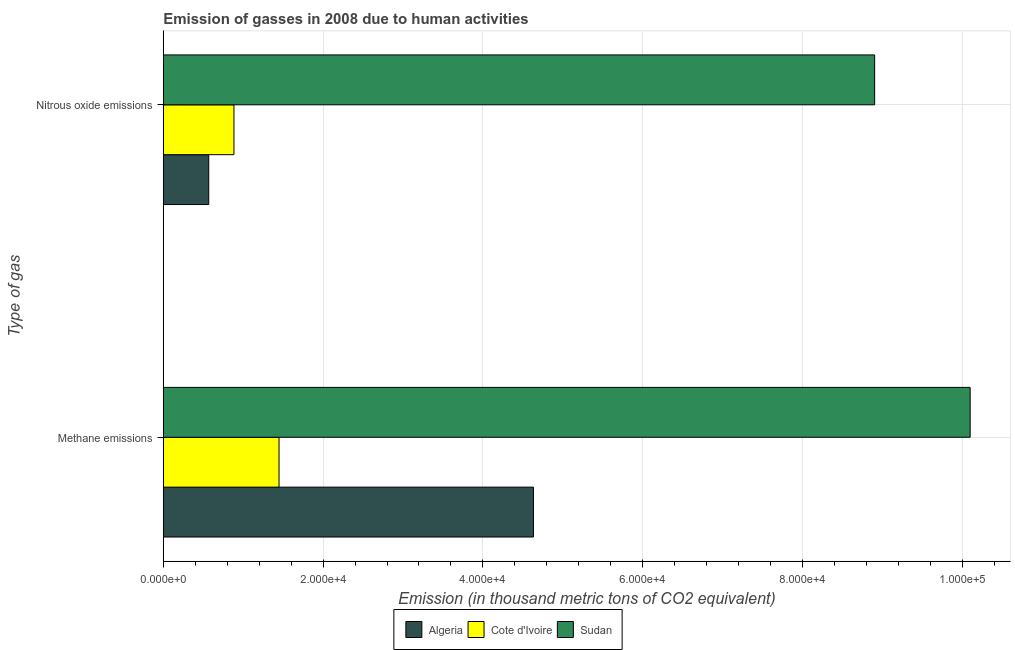How many different coloured bars are there?
Your answer should be very brief. 3. How many groups of bars are there?
Provide a succinct answer. 2. Are the number of bars per tick equal to the number of legend labels?
Offer a terse response. Yes. How many bars are there on the 1st tick from the bottom?
Offer a terse response. 3. What is the label of the 1st group of bars from the top?
Give a very brief answer. Nitrous oxide emissions. What is the amount of methane emissions in Algeria?
Make the answer very short. 4.63e+04. Across all countries, what is the maximum amount of nitrous oxide emissions?
Your answer should be very brief. 8.90e+04. Across all countries, what is the minimum amount of methane emissions?
Offer a very short reply. 1.45e+04. In which country was the amount of nitrous oxide emissions maximum?
Ensure brevity in your answer.  Sudan. In which country was the amount of nitrous oxide emissions minimum?
Make the answer very short. Algeria. What is the total amount of methane emissions in the graph?
Keep it short and to the point. 1.62e+05. What is the difference between the amount of methane emissions in Algeria and that in Cote d'Ivoire?
Provide a succinct answer. 3.18e+04. What is the difference between the amount of methane emissions in Cote d'Ivoire and the amount of nitrous oxide emissions in Sudan?
Offer a very short reply. -7.45e+04. What is the average amount of nitrous oxide emissions per country?
Your response must be concise. 3.45e+04. What is the difference between the amount of nitrous oxide emissions and amount of methane emissions in Sudan?
Provide a succinct answer. -1.20e+04. In how many countries, is the amount of methane emissions greater than 48000 thousand metric tons?
Provide a short and direct response. 1. What is the ratio of the amount of methane emissions in Algeria to that in Sudan?
Give a very brief answer. 0.46. Is the amount of nitrous oxide emissions in Cote d'Ivoire less than that in Sudan?
Ensure brevity in your answer.  Yes. In how many countries, is the amount of methane emissions greater than the average amount of methane emissions taken over all countries?
Your answer should be very brief. 1. What does the 2nd bar from the top in Nitrous oxide emissions represents?
Your response must be concise. Cote d'Ivoire. What does the 1st bar from the bottom in Methane emissions represents?
Ensure brevity in your answer.  Algeria. How many bars are there?
Your answer should be very brief. 6. Are all the bars in the graph horizontal?
Your answer should be compact. Yes. What is the difference between two consecutive major ticks on the X-axis?
Ensure brevity in your answer.  2.00e+04. Are the values on the major ticks of X-axis written in scientific E-notation?
Offer a terse response. Yes. How are the legend labels stacked?
Your answer should be very brief. Horizontal. What is the title of the graph?
Offer a terse response. Emission of gasses in 2008 due to human activities. What is the label or title of the X-axis?
Offer a terse response. Emission (in thousand metric tons of CO2 equivalent). What is the label or title of the Y-axis?
Your response must be concise. Type of gas. What is the Emission (in thousand metric tons of CO2 equivalent) of Algeria in Methane emissions?
Keep it short and to the point. 4.63e+04. What is the Emission (in thousand metric tons of CO2 equivalent) of Cote d'Ivoire in Methane emissions?
Give a very brief answer. 1.45e+04. What is the Emission (in thousand metric tons of CO2 equivalent) of Sudan in Methane emissions?
Keep it short and to the point. 1.01e+05. What is the Emission (in thousand metric tons of CO2 equivalent) in Algeria in Nitrous oxide emissions?
Offer a very short reply. 5687.2. What is the Emission (in thousand metric tons of CO2 equivalent) in Cote d'Ivoire in Nitrous oxide emissions?
Your answer should be compact. 8843.3. What is the Emission (in thousand metric tons of CO2 equivalent) of Sudan in Nitrous oxide emissions?
Make the answer very short. 8.90e+04. Across all Type of gas, what is the maximum Emission (in thousand metric tons of CO2 equivalent) in Algeria?
Ensure brevity in your answer.  4.63e+04. Across all Type of gas, what is the maximum Emission (in thousand metric tons of CO2 equivalent) of Cote d'Ivoire?
Your answer should be very brief. 1.45e+04. Across all Type of gas, what is the maximum Emission (in thousand metric tons of CO2 equivalent) of Sudan?
Your answer should be compact. 1.01e+05. Across all Type of gas, what is the minimum Emission (in thousand metric tons of CO2 equivalent) in Algeria?
Your answer should be very brief. 5687.2. Across all Type of gas, what is the minimum Emission (in thousand metric tons of CO2 equivalent) of Cote d'Ivoire?
Offer a very short reply. 8843.3. Across all Type of gas, what is the minimum Emission (in thousand metric tons of CO2 equivalent) of Sudan?
Make the answer very short. 8.90e+04. What is the total Emission (in thousand metric tons of CO2 equivalent) of Algeria in the graph?
Your answer should be very brief. 5.20e+04. What is the total Emission (in thousand metric tons of CO2 equivalent) in Cote d'Ivoire in the graph?
Your response must be concise. 2.33e+04. What is the total Emission (in thousand metric tons of CO2 equivalent) in Sudan in the graph?
Give a very brief answer. 1.90e+05. What is the difference between the Emission (in thousand metric tons of CO2 equivalent) in Algeria in Methane emissions and that in Nitrous oxide emissions?
Your response must be concise. 4.06e+04. What is the difference between the Emission (in thousand metric tons of CO2 equivalent) in Cote d'Ivoire in Methane emissions and that in Nitrous oxide emissions?
Give a very brief answer. 5643.3. What is the difference between the Emission (in thousand metric tons of CO2 equivalent) in Sudan in Methane emissions and that in Nitrous oxide emissions?
Provide a succinct answer. 1.20e+04. What is the difference between the Emission (in thousand metric tons of CO2 equivalent) of Algeria in Methane emissions and the Emission (in thousand metric tons of CO2 equivalent) of Cote d'Ivoire in Nitrous oxide emissions?
Provide a succinct answer. 3.75e+04. What is the difference between the Emission (in thousand metric tons of CO2 equivalent) in Algeria in Methane emissions and the Emission (in thousand metric tons of CO2 equivalent) in Sudan in Nitrous oxide emissions?
Offer a terse response. -4.27e+04. What is the difference between the Emission (in thousand metric tons of CO2 equivalent) of Cote d'Ivoire in Methane emissions and the Emission (in thousand metric tons of CO2 equivalent) of Sudan in Nitrous oxide emissions?
Ensure brevity in your answer.  -7.45e+04. What is the average Emission (in thousand metric tons of CO2 equivalent) of Algeria per Type of gas?
Your answer should be compact. 2.60e+04. What is the average Emission (in thousand metric tons of CO2 equivalent) in Cote d'Ivoire per Type of gas?
Your response must be concise. 1.17e+04. What is the average Emission (in thousand metric tons of CO2 equivalent) of Sudan per Type of gas?
Provide a succinct answer. 9.50e+04. What is the difference between the Emission (in thousand metric tons of CO2 equivalent) in Algeria and Emission (in thousand metric tons of CO2 equivalent) in Cote d'Ivoire in Methane emissions?
Your answer should be very brief. 3.18e+04. What is the difference between the Emission (in thousand metric tons of CO2 equivalent) of Algeria and Emission (in thousand metric tons of CO2 equivalent) of Sudan in Methane emissions?
Offer a terse response. -5.47e+04. What is the difference between the Emission (in thousand metric tons of CO2 equivalent) in Cote d'Ivoire and Emission (in thousand metric tons of CO2 equivalent) in Sudan in Methane emissions?
Give a very brief answer. -8.65e+04. What is the difference between the Emission (in thousand metric tons of CO2 equivalent) in Algeria and Emission (in thousand metric tons of CO2 equivalent) in Cote d'Ivoire in Nitrous oxide emissions?
Give a very brief answer. -3156.1. What is the difference between the Emission (in thousand metric tons of CO2 equivalent) of Algeria and Emission (in thousand metric tons of CO2 equivalent) of Sudan in Nitrous oxide emissions?
Keep it short and to the point. -8.33e+04. What is the difference between the Emission (in thousand metric tons of CO2 equivalent) in Cote d'Ivoire and Emission (in thousand metric tons of CO2 equivalent) in Sudan in Nitrous oxide emissions?
Keep it short and to the point. -8.02e+04. What is the ratio of the Emission (in thousand metric tons of CO2 equivalent) of Algeria in Methane emissions to that in Nitrous oxide emissions?
Provide a short and direct response. 8.15. What is the ratio of the Emission (in thousand metric tons of CO2 equivalent) in Cote d'Ivoire in Methane emissions to that in Nitrous oxide emissions?
Your answer should be compact. 1.64. What is the ratio of the Emission (in thousand metric tons of CO2 equivalent) in Sudan in Methane emissions to that in Nitrous oxide emissions?
Make the answer very short. 1.13. What is the difference between the highest and the second highest Emission (in thousand metric tons of CO2 equivalent) in Algeria?
Keep it short and to the point. 4.06e+04. What is the difference between the highest and the second highest Emission (in thousand metric tons of CO2 equivalent) of Cote d'Ivoire?
Keep it short and to the point. 5643.3. What is the difference between the highest and the second highest Emission (in thousand metric tons of CO2 equivalent) of Sudan?
Offer a terse response. 1.20e+04. What is the difference between the highest and the lowest Emission (in thousand metric tons of CO2 equivalent) of Algeria?
Keep it short and to the point. 4.06e+04. What is the difference between the highest and the lowest Emission (in thousand metric tons of CO2 equivalent) of Cote d'Ivoire?
Keep it short and to the point. 5643.3. What is the difference between the highest and the lowest Emission (in thousand metric tons of CO2 equivalent) in Sudan?
Your answer should be compact. 1.20e+04. 